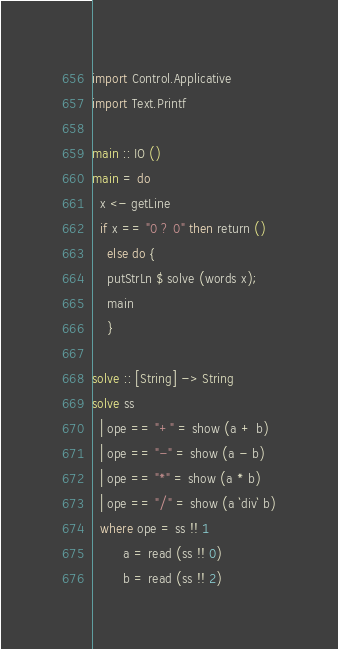<code> <loc_0><loc_0><loc_500><loc_500><_Haskell_>import Control.Applicative
import Text.Printf

main :: IO ()
main = do
  x <- getLine
  if x == "0 ? 0" then return ()
    else do {
    putStrLn $ solve (words x);
    main
    }
         
solve :: [String] -> String
solve ss
  | ope == "+" = show (a + b)
  | ope == "-" = show (a - b)
  | ope == "*" = show (a * b)
  | ope == "/" = show (a `div` b)
  where ope = ss !! 1
        a = read (ss !! 0)
        b = read (ss !! 2)</code> 